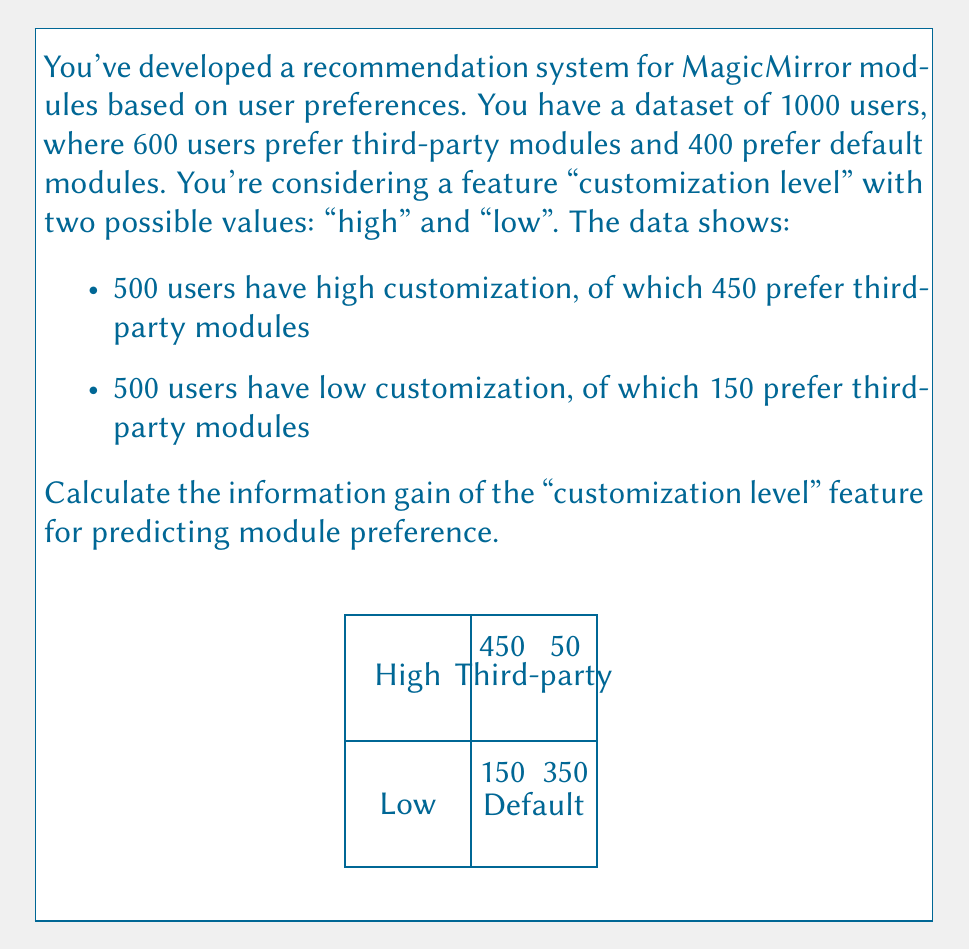Provide a solution to this math problem. Let's solve this step-by-step:

1) First, calculate the entropy of the target variable (module preference):
   $$H(Y) = -\sum_{i} p(y_i) \log_2 p(y_i)$$
   $$H(Y) = -(\frac{600}{1000} \log_2 \frac{600}{1000} + \frac{400}{1000} \log_2 \frac{400}{1000}) \approx 0.9710$$

2) Now, calculate the conditional entropy for each value of the feature:

   For high customization:
   $$H(Y|X=high) = -(\frac{450}{500} \log_2 \frac{450}{500} + \frac{50}{500} \log_2 \frac{50}{500}) \approx 0.4427$$

   For low customization:
   $$H(Y|X=low) = -(\frac{150}{500} \log_2 \frac{150}{500} + \frac{350}{500} \log_2 \frac{350}{500}) \approx 0.8813$$

3) Calculate the weighted average of these conditional entropies:
   $$H(Y|X) = \sum_{j} p(x_j) H(Y|X=x_j)$$
   $$H(Y|X) = \frac{500}{1000} * 0.4427 + \frac{500}{1000} * 0.8813 = 0.6620$$

4) Finally, calculate the information gain:
   $$IG(Y,X) = H(Y) - H(Y|X)$$
   $$IG(Y,X) = 0.9710 - 0.6620 = 0.3090$$
Answer: 0.3090 bits 